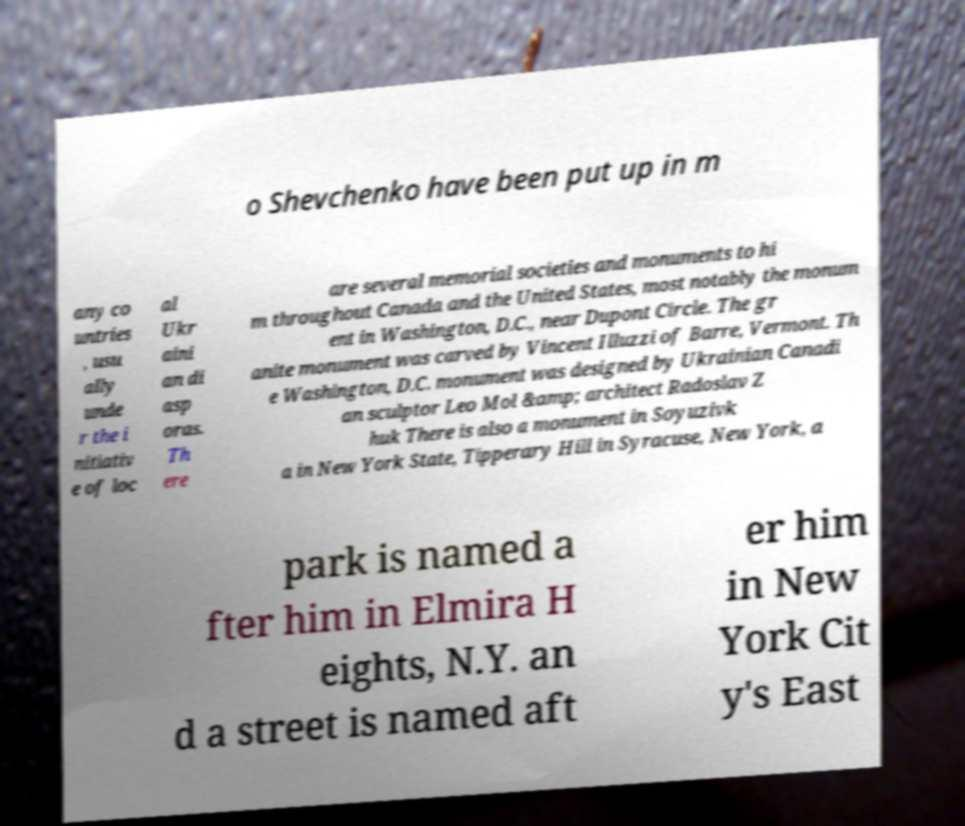There's text embedded in this image that I need extracted. Can you transcribe it verbatim? o Shevchenko have been put up in m any co untries , usu ally unde r the i nitiativ e of loc al Ukr aini an di asp oras. Th ere are several memorial societies and monuments to hi m throughout Canada and the United States, most notably the monum ent in Washington, D.C., near Dupont Circle. The gr anite monument was carved by Vincent Illuzzi of Barre, Vermont. Th e Washington, D.C. monument was designed by Ukrainian Canadi an sculptor Leo Mol &amp; architect Radoslav Z huk There is also a monument in Soyuzivk a in New York State, Tipperary Hill in Syracuse, New York, a park is named a fter him in Elmira H eights, N.Y. an d a street is named aft er him in New York Cit y's East 